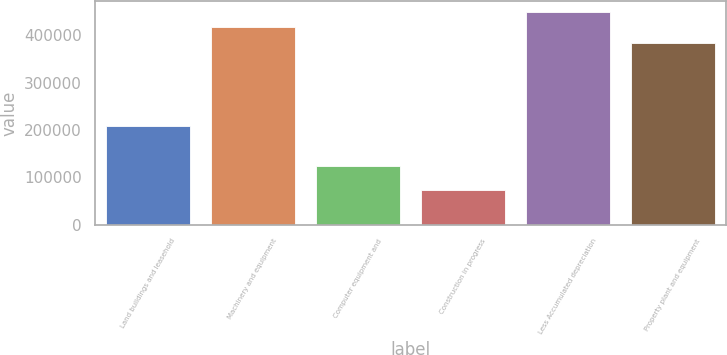Convert chart to OTSL. <chart><loc_0><loc_0><loc_500><loc_500><bar_chart><fcel>Land buildings and leasehold<fcel>Machinery and equipment<fcel>Computer equipment and<fcel>Construction in progress<fcel>Less Accumulated depreciation<fcel>Property plant and equipment<nl><fcel>207927<fcel>416252<fcel>122890<fcel>73920<fcel>449505<fcel>382999<nl></chart> 